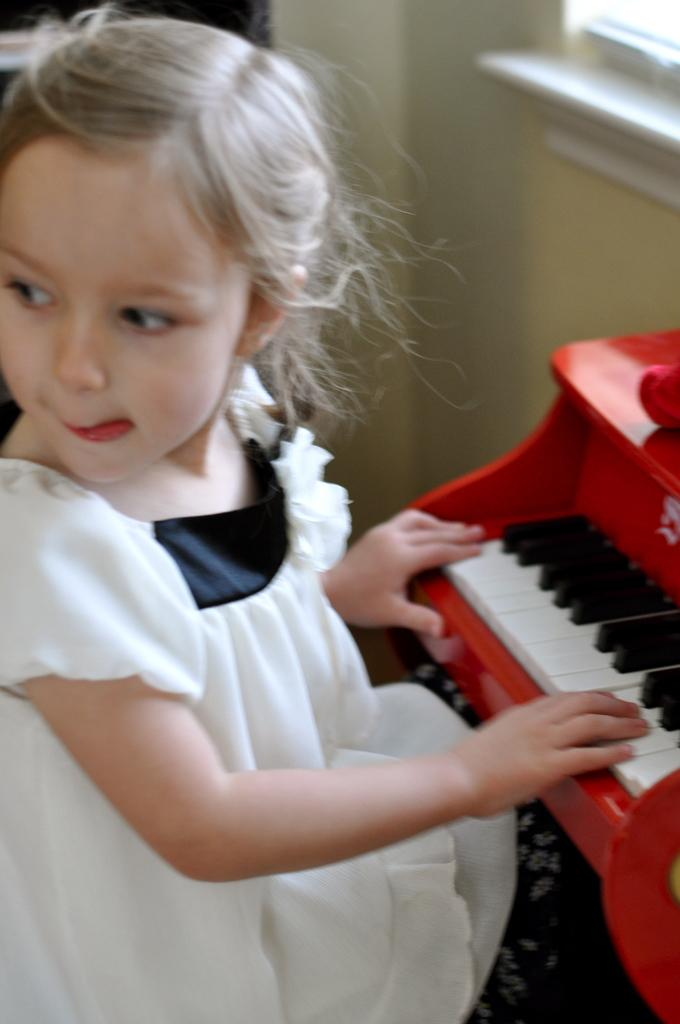Who is the main subject in the image? There is a girl in the image. What is the girl doing in the image? The girl is playing a keyboard. What is the girl wearing in the image? The girl is wearing a white frock. What is the color of the girl's hair in the image? The girl's hair color is light grey. What can be seen in the background of the image? There is a wall in the image. What type of eggnog is being served at the place in the image? There is no place or eggnog mentioned in the image; it features a girl playing a keyboard. 